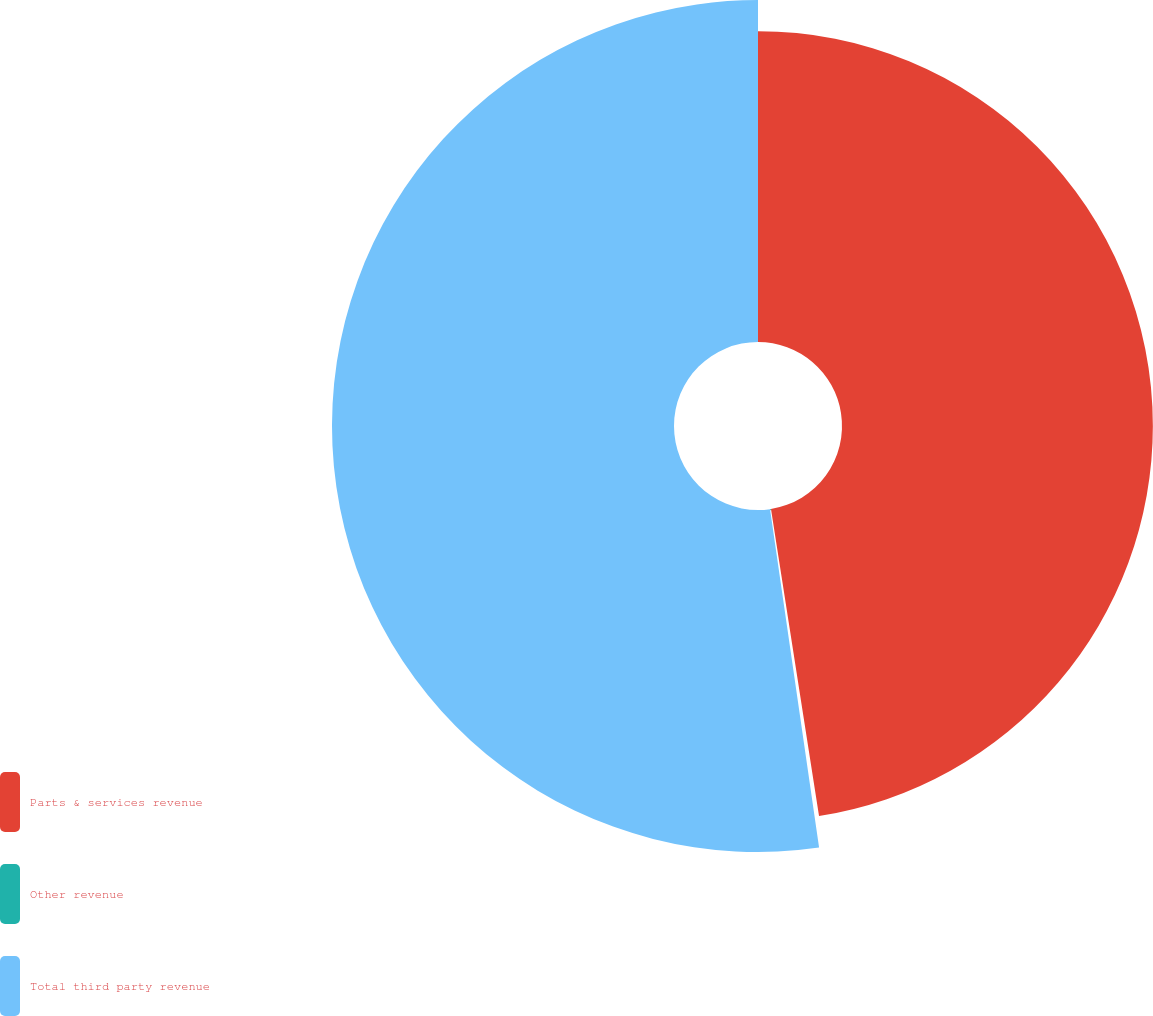Convert chart to OTSL. <chart><loc_0><loc_0><loc_500><loc_500><pie_chart><fcel>Parts & services revenue<fcel>Other revenue<fcel>Total third party revenue<nl><fcel>47.53%<fcel>0.18%<fcel>52.29%<nl></chart> 